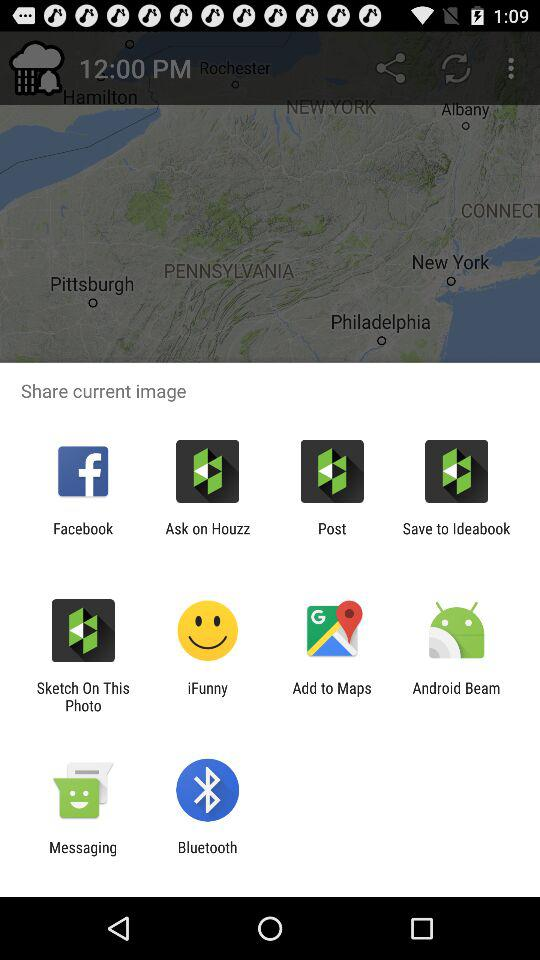What are the options to share? The options to share are "Facebook", "Ask to Houzz", "Post", "Save to Ideabook", "Sketch On This Photo", "iFunny", "Add to Maps", "Android Beam", "Messaging" and "Bluetooth". 